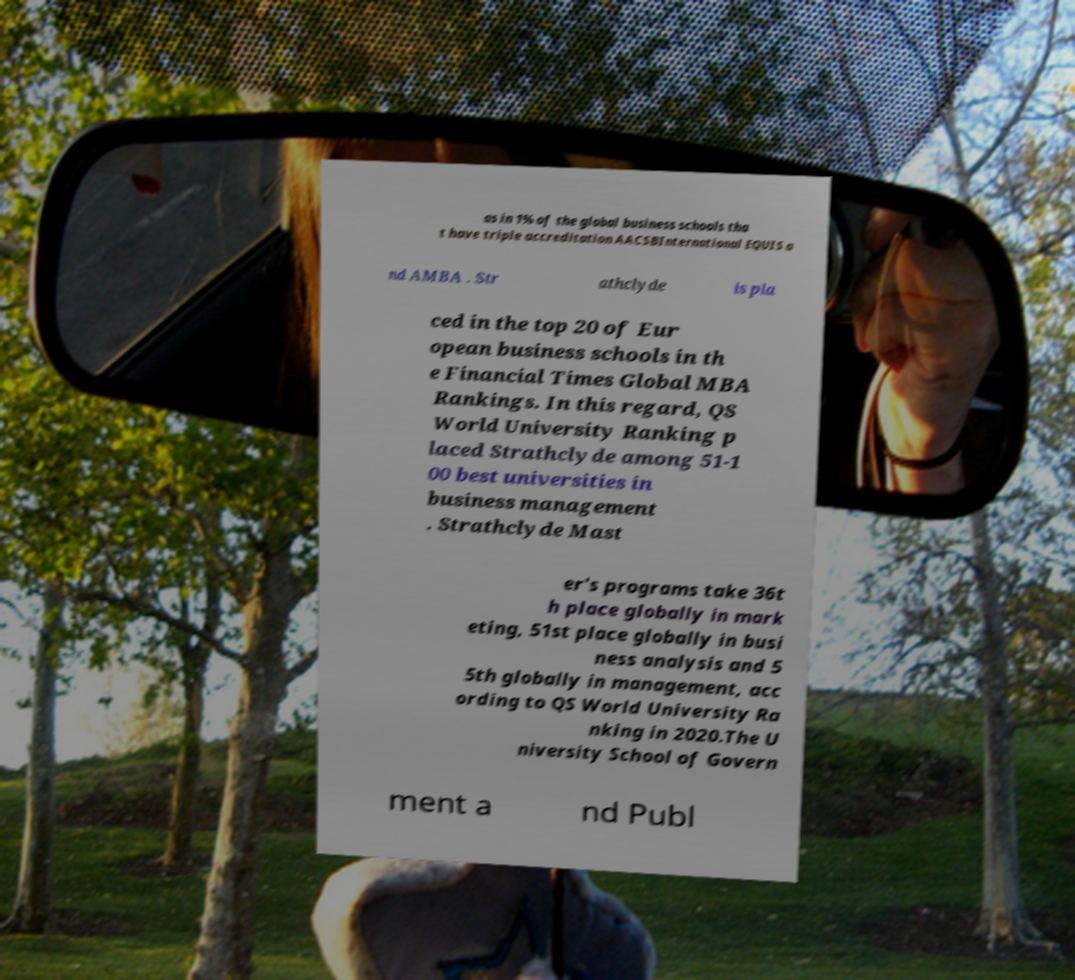For documentation purposes, I need the text within this image transcribed. Could you provide that? as in 1% of the global business schools tha t have triple accreditation AACSBInternational EQUIS a nd AMBA . Str athclyde is pla ced in the top 20 of Eur opean business schools in th e Financial Times Global MBA Rankings. In this regard, QS World University Ranking p laced Strathclyde among 51-1 00 best universities in business management . Strathclyde Mast er's programs take 36t h place globally in mark eting, 51st place globally in busi ness analysis and 5 5th globally in management, acc ording to QS World University Ra nking in 2020.The U niversity School of Govern ment a nd Publ 